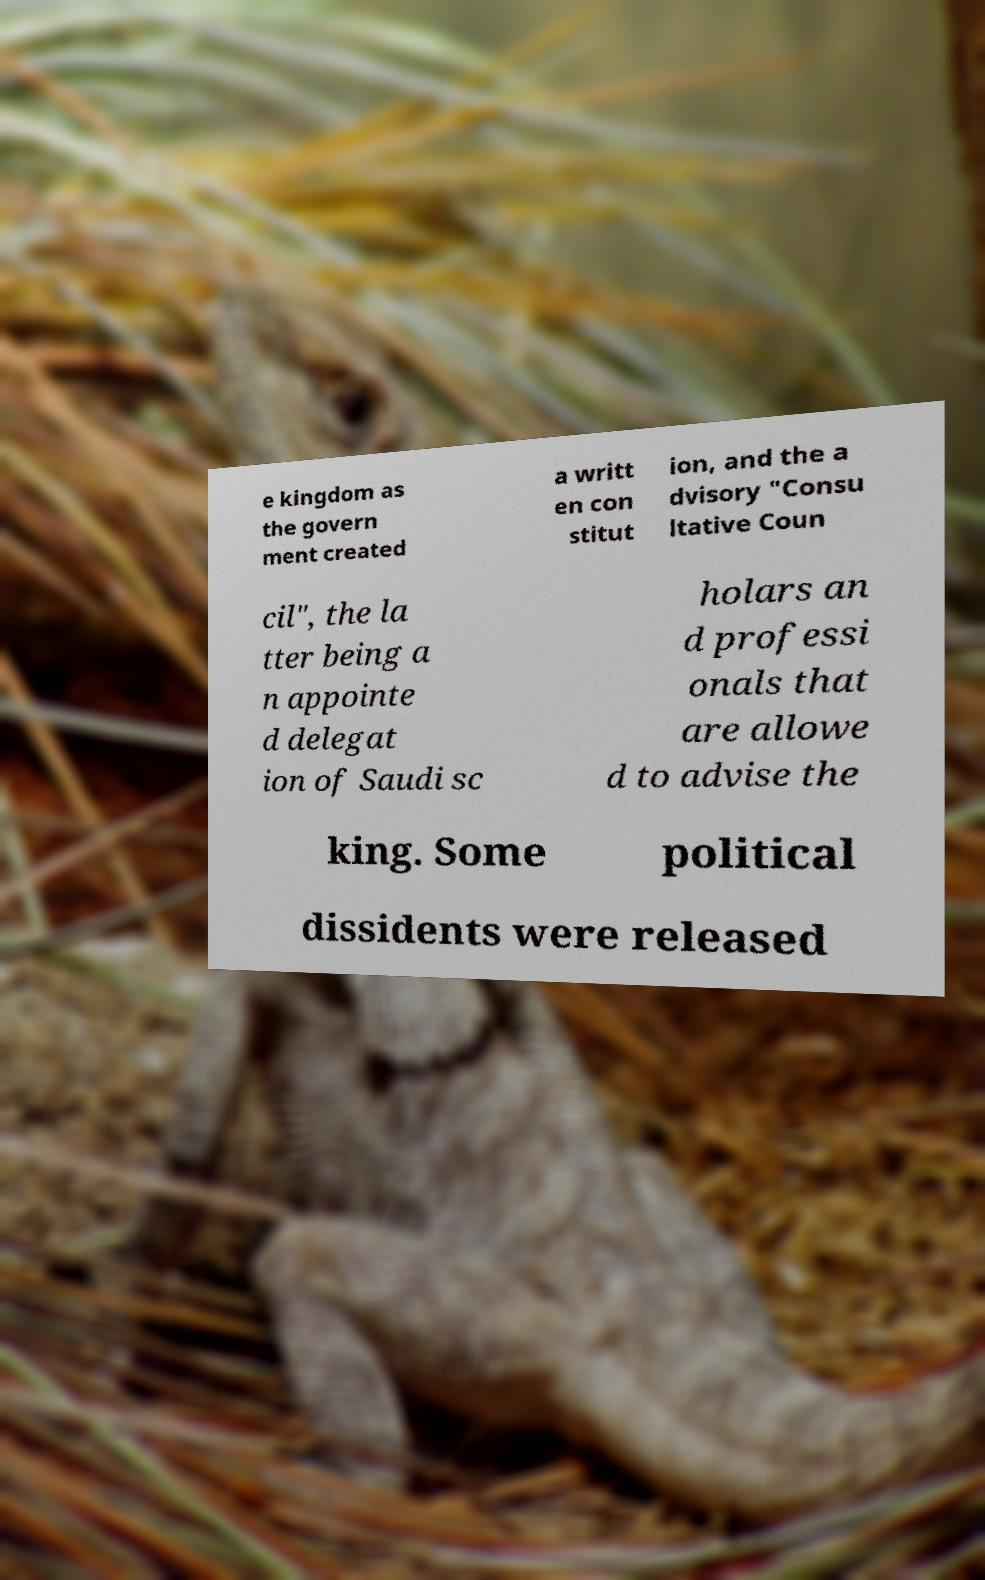Please read and relay the text visible in this image. What does it say? e kingdom as the govern ment created a writt en con stitut ion, and the a dvisory "Consu ltative Coun cil", the la tter being a n appointe d delegat ion of Saudi sc holars an d professi onals that are allowe d to advise the king. Some political dissidents were released 